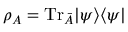Convert formula to latex. <formula><loc_0><loc_0><loc_500><loc_500>\rho _ { A } = T r _ { \bar { A } } | \psi \rangle \langle \psi |</formula> 